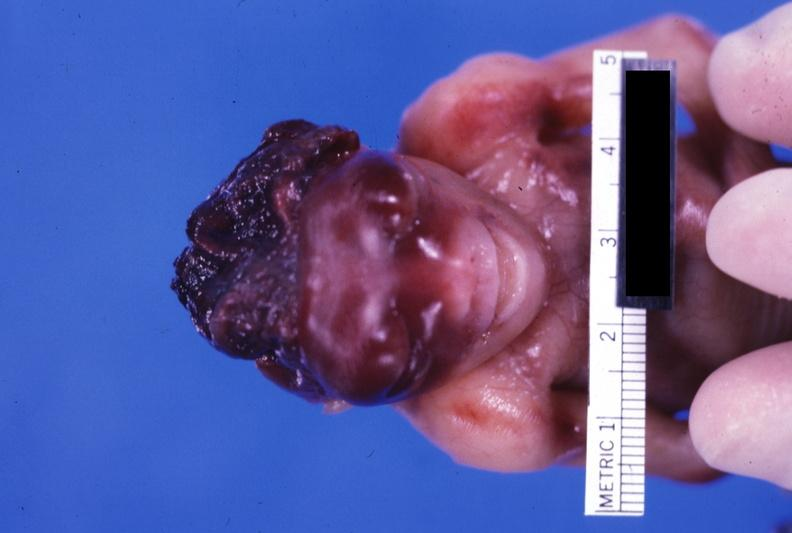what is present?
Answer the question using a single word or phrase. Anencephaly 